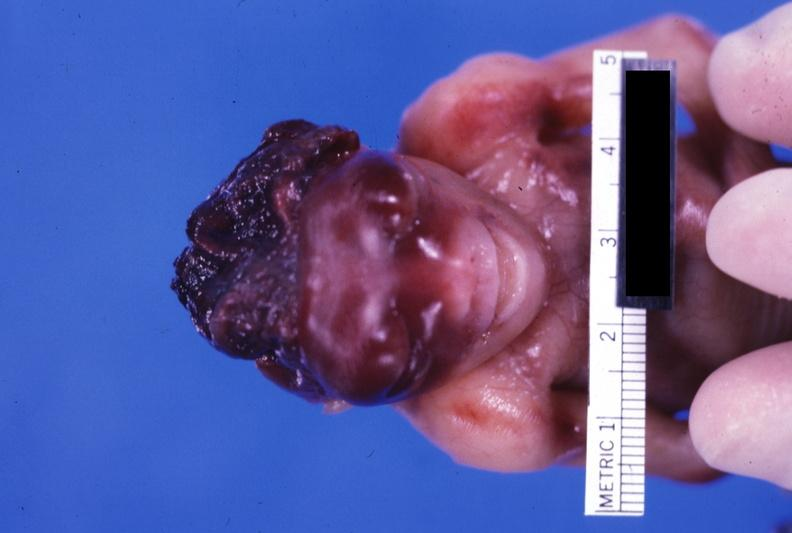what is present?
Answer the question using a single word or phrase. Anencephaly 